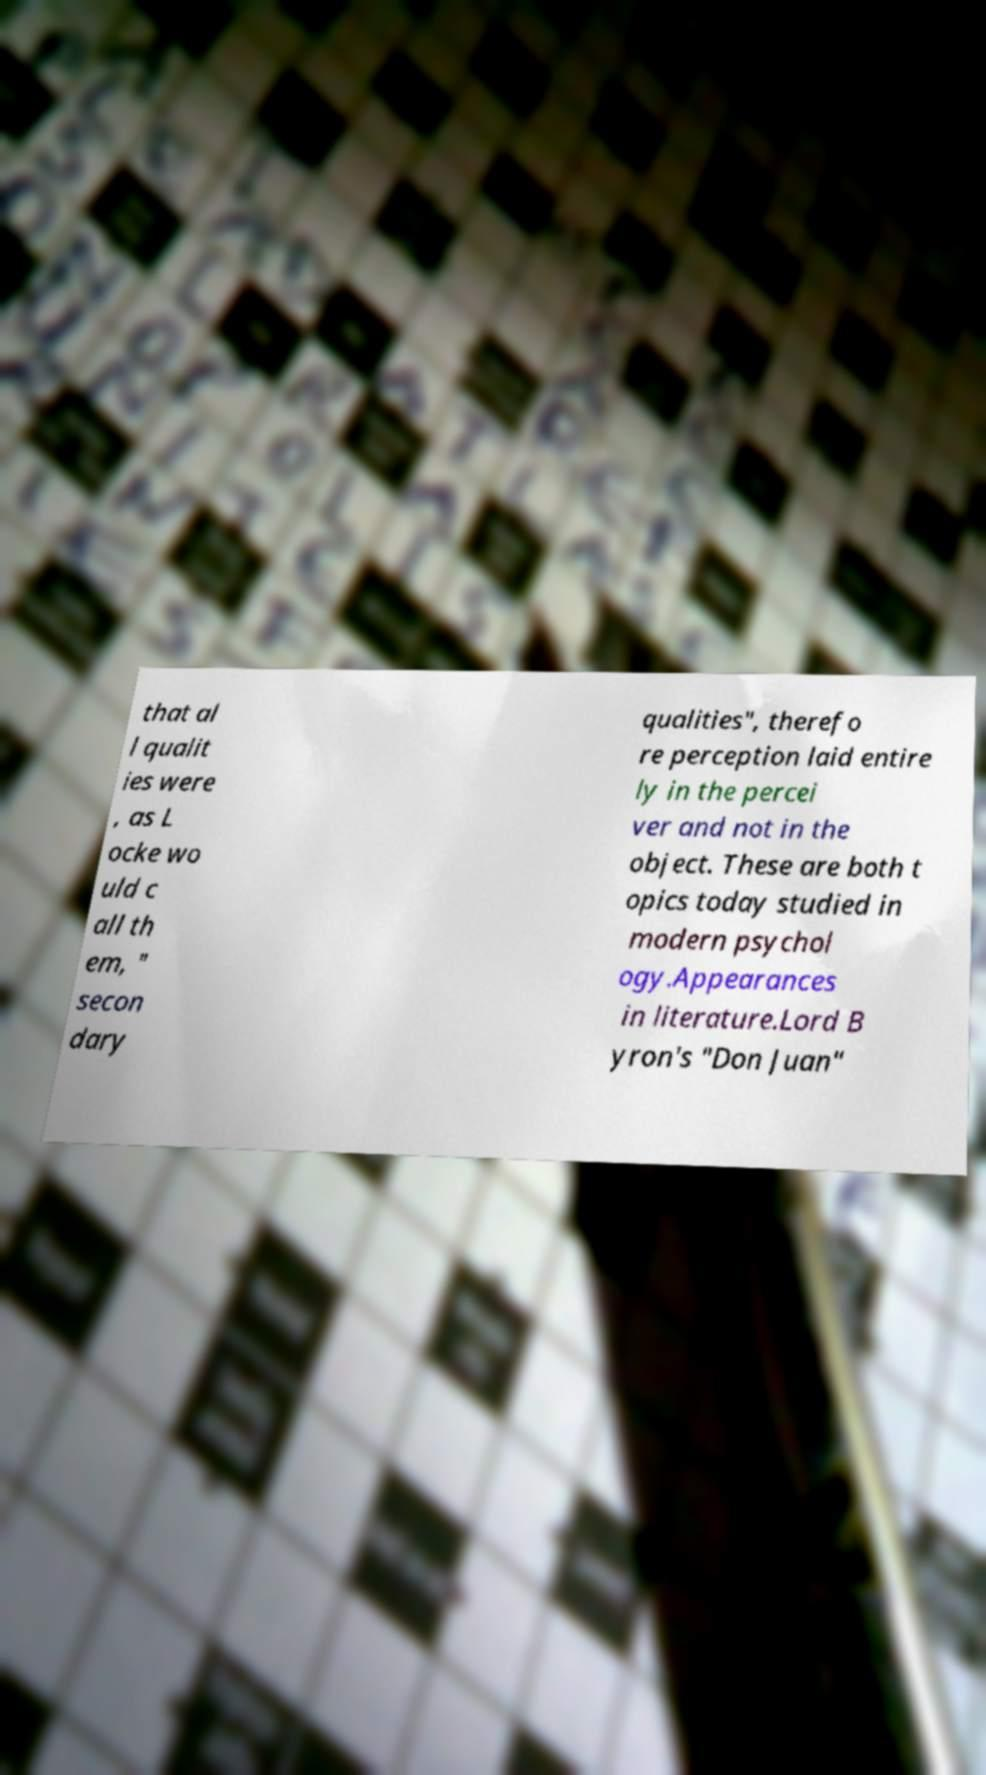I need the written content from this picture converted into text. Can you do that? that al l qualit ies were , as L ocke wo uld c all th em, " secon dary qualities", therefo re perception laid entire ly in the percei ver and not in the object. These are both t opics today studied in modern psychol ogy.Appearances in literature.Lord B yron's "Don Juan" 